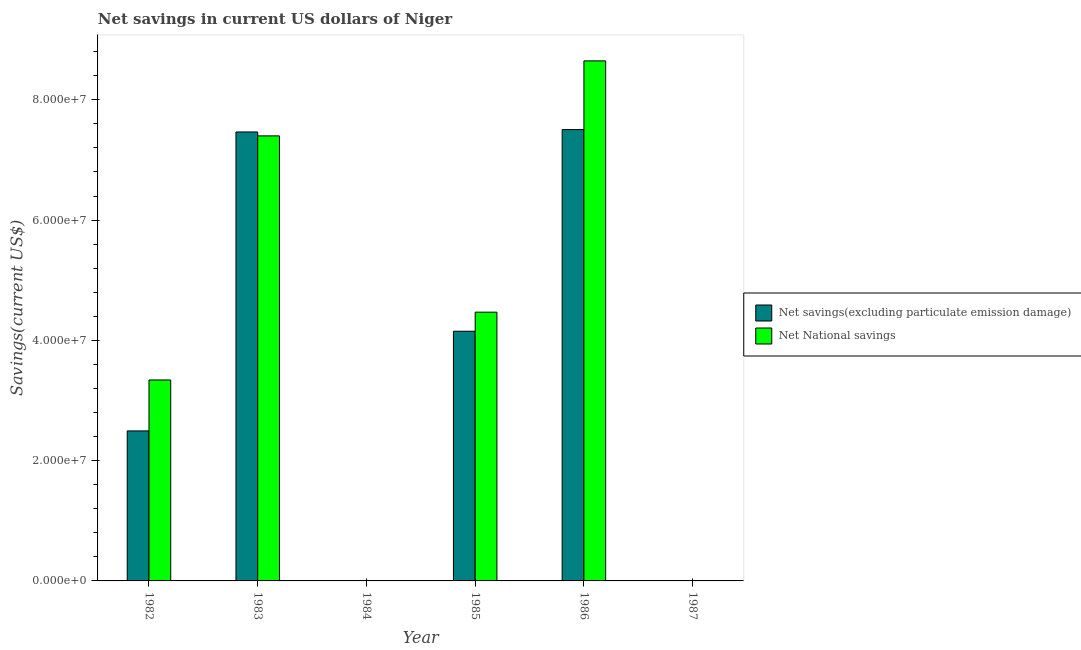Are the number of bars per tick equal to the number of legend labels?
Offer a very short reply. No. Are the number of bars on each tick of the X-axis equal?
Make the answer very short. No. How many bars are there on the 5th tick from the right?
Give a very brief answer. 2. What is the label of the 1st group of bars from the left?
Ensure brevity in your answer.  1982. What is the net national savings in 1984?
Ensure brevity in your answer.  0. Across all years, what is the maximum net national savings?
Ensure brevity in your answer.  8.65e+07. Across all years, what is the minimum net national savings?
Offer a very short reply. 0. What is the total net savings(excluding particulate emission damage) in the graph?
Provide a succinct answer. 2.16e+08. What is the difference between the net savings(excluding particulate emission damage) in 1982 and that in 1985?
Ensure brevity in your answer.  -1.66e+07. What is the difference between the net national savings in 1984 and the net savings(excluding particulate emission damage) in 1986?
Make the answer very short. -8.65e+07. What is the average net national savings per year?
Your answer should be compact. 3.98e+07. In the year 1983, what is the difference between the net national savings and net savings(excluding particulate emission damage)?
Offer a very short reply. 0. Is the difference between the net national savings in 1982 and 1986 greater than the difference between the net savings(excluding particulate emission damage) in 1982 and 1986?
Your response must be concise. No. What is the difference between the highest and the second highest net savings(excluding particulate emission damage)?
Ensure brevity in your answer.  3.97e+05. What is the difference between the highest and the lowest net savings(excluding particulate emission damage)?
Provide a succinct answer. 7.51e+07. In how many years, is the net national savings greater than the average net national savings taken over all years?
Ensure brevity in your answer.  3. How many bars are there?
Ensure brevity in your answer.  8. How many years are there in the graph?
Ensure brevity in your answer.  6. What is the difference between two consecutive major ticks on the Y-axis?
Your response must be concise. 2.00e+07. Are the values on the major ticks of Y-axis written in scientific E-notation?
Provide a succinct answer. Yes. Does the graph contain any zero values?
Make the answer very short. Yes. How are the legend labels stacked?
Keep it short and to the point. Vertical. What is the title of the graph?
Offer a very short reply. Net savings in current US dollars of Niger. Does "Foreign Liabilities" appear as one of the legend labels in the graph?
Provide a short and direct response. No. What is the label or title of the Y-axis?
Provide a succinct answer. Savings(current US$). What is the Savings(current US$) of Net savings(excluding particulate emission damage) in 1982?
Give a very brief answer. 2.49e+07. What is the Savings(current US$) in Net National savings in 1982?
Offer a very short reply. 3.34e+07. What is the Savings(current US$) of Net savings(excluding particulate emission damage) in 1983?
Your response must be concise. 7.47e+07. What is the Savings(current US$) of Net National savings in 1983?
Your answer should be very brief. 7.40e+07. What is the Savings(current US$) in Net National savings in 1984?
Your response must be concise. 0. What is the Savings(current US$) in Net savings(excluding particulate emission damage) in 1985?
Offer a terse response. 4.15e+07. What is the Savings(current US$) of Net National savings in 1985?
Offer a very short reply. 4.47e+07. What is the Savings(current US$) of Net savings(excluding particulate emission damage) in 1986?
Provide a short and direct response. 7.51e+07. What is the Savings(current US$) of Net National savings in 1986?
Give a very brief answer. 8.65e+07. Across all years, what is the maximum Savings(current US$) of Net savings(excluding particulate emission damage)?
Ensure brevity in your answer.  7.51e+07. Across all years, what is the maximum Savings(current US$) of Net National savings?
Your answer should be compact. 8.65e+07. What is the total Savings(current US$) of Net savings(excluding particulate emission damage) in the graph?
Offer a very short reply. 2.16e+08. What is the total Savings(current US$) of Net National savings in the graph?
Provide a succinct answer. 2.39e+08. What is the difference between the Savings(current US$) of Net savings(excluding particulate emission damage) in 1982 and that in 1983?
Make the answer very short. -4.97e+07. What is the difference between the Savings(current US$) in Net National savings in 1982 and that in 1983?
Offer a terse response. -4.06e+07. What is the difference between the Savings(current US$) of Net savings(excluding particulate emission damage) in 1982 and that in 1985?
Provide a short and direct response. -1.66e+07. What is the difference between the Savings(current US$) of Net National savings in 1982 and that in 1985?
Make the answer very short. -1.13e+07. What is the difference between the Savings(current US$) of Net savings(excluding particulate emission damage) in 1982 and that in 1986?
Your response must be concise. -5.01e+07. What is the difference between the Savings(current US$) in Net National savings in 1982 and that in 1986?
Ensure brevity in your answer.  -5.31e+07. What is the difference between the Savings(current US$) in Net savings(excluding particulate emission damage) in 1983 and that in 1985?
Keep it short and to the point. 3.31e+07. What is the difference between the Savings(current US$) of Net National savings in 1983 and that in 1985?
Your answer should be very brief. 2.93e+07. What is the difference between the Savings(current US$) of Net savings(excluding particulate emission damage) in 1983 and that in 1986?
Your response must be concise. -3.97e+05. What is the difference between the Savings(current US$) of Net National savings in 1983 and that in 1986?
Provide a succinct answer. -1.25e+07. What is the difference between the Savings(current US$) in Net savings(excluding particulate emission damage) in 1985 and that in 1986?
Give a very brief answer. -3.35e+07. What is the difference between the Savings(current US$) of Net National savings in 1985 and that in 1986?
Ensure brevity in your answer.  -4.18e+07. What is the difference between the Savings(current US$) in Net savings(excluding particulate emission damage) in 1982 and the Savings(current US$) in Net National savings in 1983?
Your response must be concise. -4.91e+07. What is the difference between the Savings(current US$) in Net savings(excluding particulate emission damage) in 1982 and the Savings(current US$) in Net National savings in 1985?
Give a very brief answer. -1.97e+07. What is the difference between the Savings(current US$) of Net savings(excluding particulate emission damage) in 1982 and the Savings(current US$) of Net National savings in 1986?
Offer a terse response. -6.15e+07. What is the difference between the Savings(current US$) in Net savings(excluding particulate emission damage) in 1983 and the Savings(current US$) in Net National savings in 1985?
Provide a succinct answer. 3.00e+07. What is the difference between the Savings(current US$) of Net savings(excluding particulate emission damage) in 1983 and the Savings(current US$) of Net National savings in 1986?
Make the answer very short. -1.18e+07. What is the difference between the Savings(current US$) in Net savings(excluding particulate emission damage) in 1985 and the Savings(current US$) in Net National savings in 1986?
Keep it short and to the point. -4.50e+07. What is the average Savings(current US$) of Net savings(excluding particulate emission damage) per year?
Keep it short and to the point. 3.60e+07. What is the average Savings(current US$) in Net National savings per year?
Ensure brevity in your answer.  3.98e+07. In the year 1982, what is the difference between the Savings(current US$) of Net savings(excluding particulate emission damage) and Savings(current US$) of Net National savings?
Your response must be concise. -8.47e+06. In the year 1983, what is the difference between the Savings(current US$) of Net savings(excluding particulate emission damage) and Savings(current US$) of Net National savings?
Make the answer very short. 6.52e+05. In the year 1985, what is the difference between the Savings(current US$) in Net savings(excluding particulate emission damage) and Savings(current US$) in Net National savings?
Offer a terse response. -3.17e+06. In the year 1986, what is the difference between the Savings(current US$) in Net savings(excluding particulate emission damage) and Savings(current US$) in Net National savings?
Your answer should be compact. -1.14e+07. What is the ratio of the Savings(current US$) in Net savings(excluding particulate emission damage) in 1982 to that in 1983?
Your answer should be very brief. 0.33. What is the ratio of the Savings(current US$) of Net National savings in 1982 to that in 1983?
Your answer should be compact. 0.45. What is the ratio of the Savings(current US$) of Net savings(excluding particulate emission damage) in 1982 to that in 1985?
Make the answer very short. 0.6. What is the ratio of the Savings(current US$) of Net National savings in 1982 to that in 1985?
Ensure brevity in your answer.  0.75. What is the ratio of the Savings(current US$) of Net savings(excluding particulate emission damage) in 1982 to that in 1986?
Make the answer very short. 0.33. What is the ratio of the Savings(current US$) in Net National savings in 1982 to that in 1986?
Offer a very short reply. 0.39. What is the ratio of the Savings(current US$) in Net savings(excluding particulate emission damage) in 1983 to that in 1985?
Make the answer very short. 1.8. What is the ratio of the Savings(current US$) of Net National savings in 1983 to that in 1985?
Keep it short and to the point. 1.66. What is the ratio of the Savings(current US$) in Net savings(excluding particulate emission damage) in 1983 to that in 1986?
Keep it short and to the point. 0.99. What is the ratio of the Savings(current US$) of Net National savings in 1983 to that in 1986?
Offer a terse response. 0.86. What is the ratio of the Savings(current US$) in Net savings(excluding particulate emission damage) in 1985 to that in 1986?
Provide a succinct answer. 0.55. What is the ratio of the Savings(current US$) of Net National savings in 1985 to that in 1986?
Provide a succinct answer. 0.52. What is the difference between the highest and the second highest Savings(current US$) of Net savings(excluding particulate emission damage)?
Ensure brevity in your answer.  3.97e+05. What is the difference between the highest and the second highest Savings(current US$) in Net National savings?
Your response must be concise. 1.25e+07. What is the difference between the highest and the lowest Savings(current US$) in Net savings(excluding particulate emission damage)?
Offer a very short reply. 7.51e+07. What is the difference between the highest and the lowest Savings(current US$) in Net National savings?
Ensure brevity in your answer.  8.65e+07. 